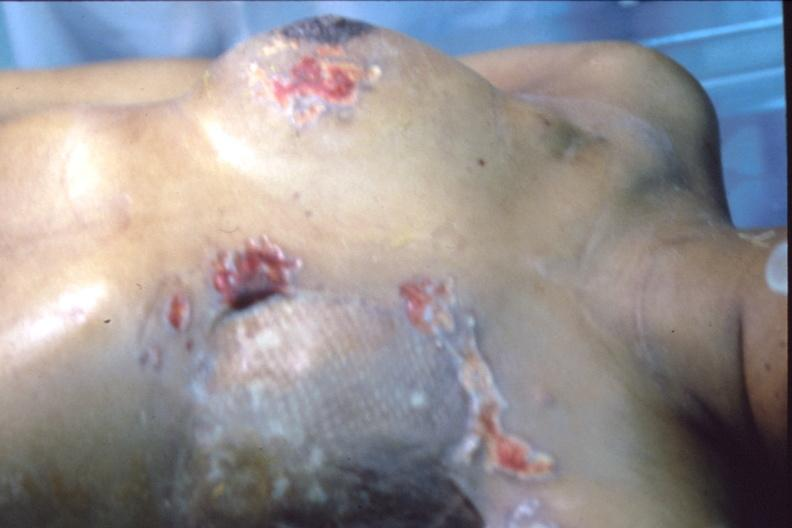where is this area in the body?
Answer the question using a single word or phrase. Breast 